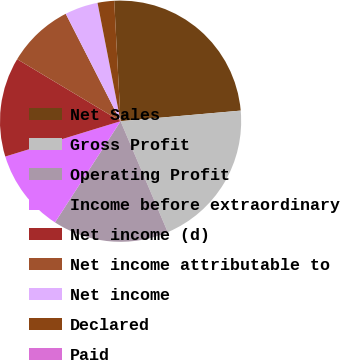<chart> <loc_0><loc_0><loc_500><loc_500><pie_chart><fcel>Net Sales<fcel>Gross Profit<fcel>Operating Profit<fcel>Income before extraordinary<fcel>Net income (d)<fcel>Net income attributable to<fcel>Net income<fcel>Declared<fcel>Paid<nl><fcel>24.44%<fcel>20.0%<fcel>15.55%<fcel>11.11%<fcel>13.33%<fcel>8.89%<fcel>4.45%<fcel>2.22%<fcel>0.0%<nl></chart> 